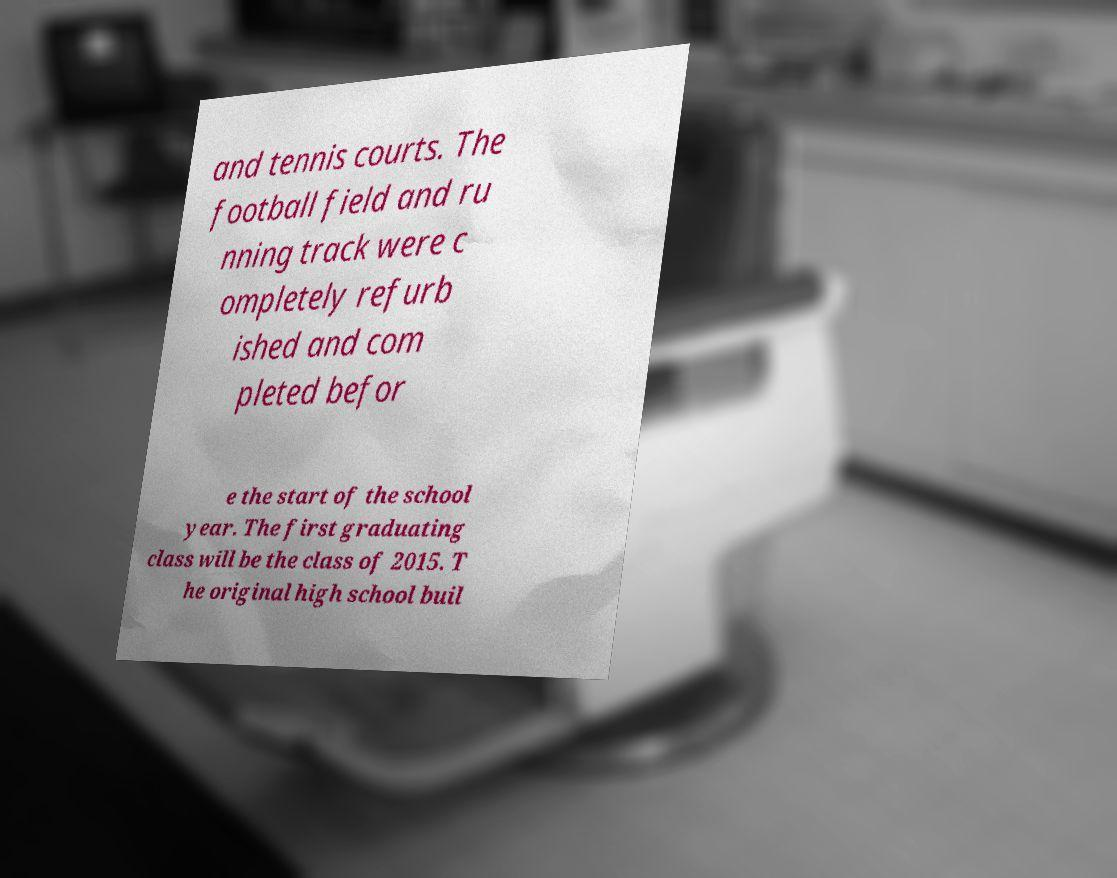Can you accurately transcribe the text from the provided image for me? and tennis courts. The football field and ru nning track were c ompletely refurb ished and com pleted befor e the start of the school year. The first graduating class will be the class of 2015. T he original high school buil 